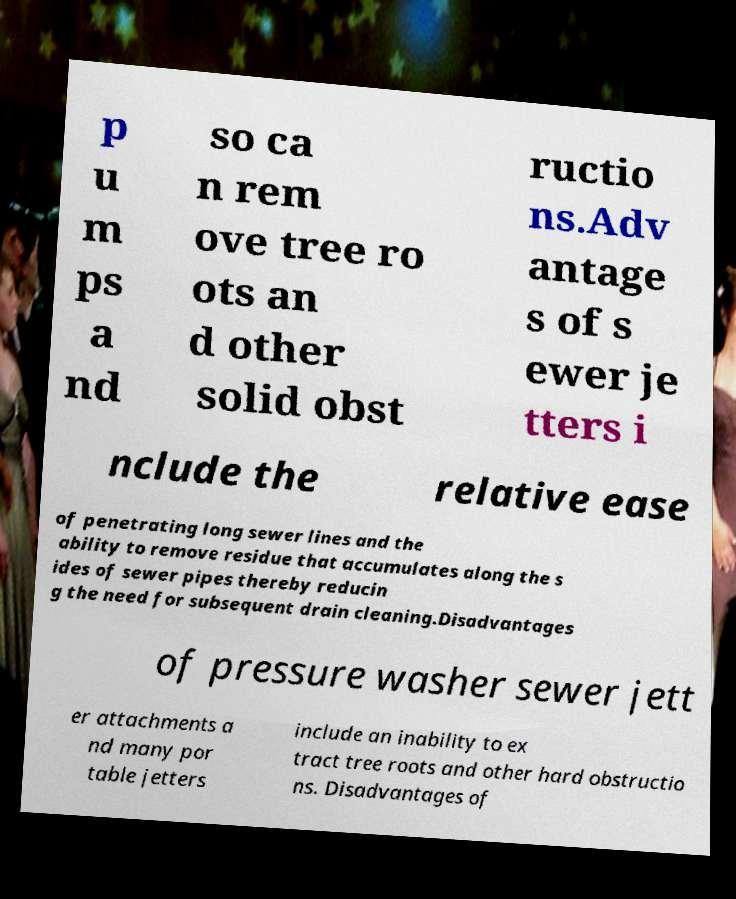For documentation purposes, I need the text within this image transcribed. Could you provide that? p u m ps a nd so ca n rem ove tree ro ots an d other solid obst ructio ns.Adv antage s of s ewer je tters i nclude the relative ease of penetrating long sewer lines and the ability to remove residue that accumulates along the s ides of sewer pipes thereby reducin g the need for subsequent drain cleaning.Disadvantages of pressure washer sewer jett er attachments a nd many por table jetters include an inability to ex tract tree roots and other hard obstructio ns. Disadvantages of 